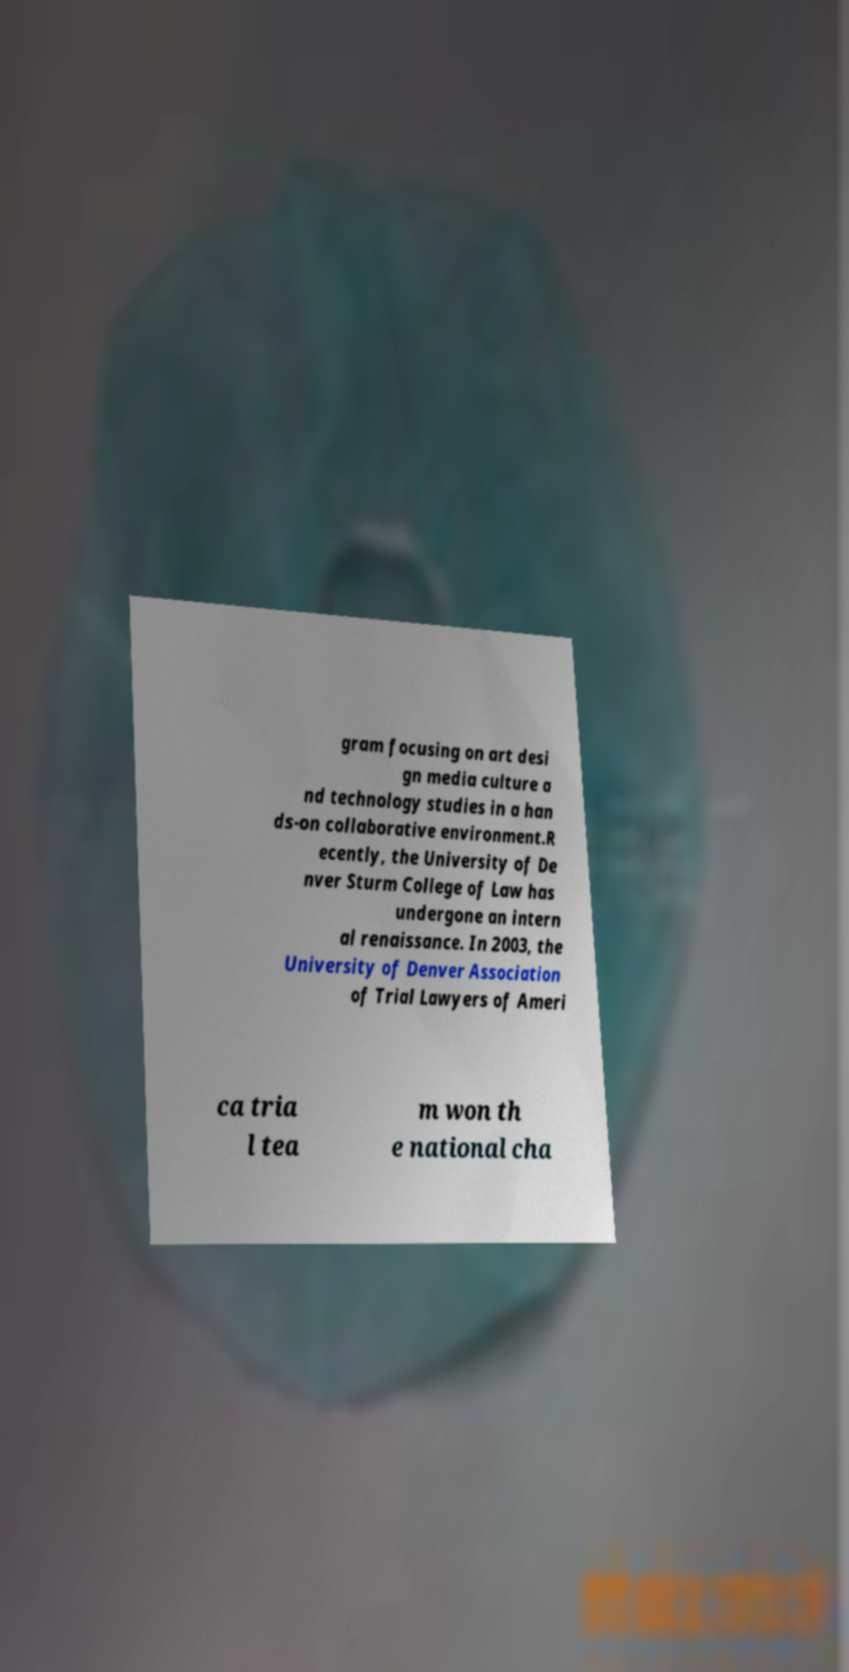What messages or text are displayed in this image? I need them in a readable, typed format. gram focusing on art desi gn media culture a nd technology studies in a han ds-on collaborative environment.R ecently, the University of De nver Sturm College of Law has undergone an intern al renaissance. In 2003, the University of Denver Association of Trial Lawyers of Ameri ca tria l tea m won th e national cha 